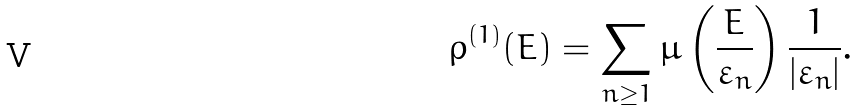<formula> <loc_0><loc_0><loc_500><loc_500>\rho ^ { ( 1 ) } ( E ) = \sum _ { n \geq 1 } \mu \left ( \frac { E } { \varepsilon _ { n } } \right ) \frac { 1 } { | \varepsilon _ { n } | } .</formula> 